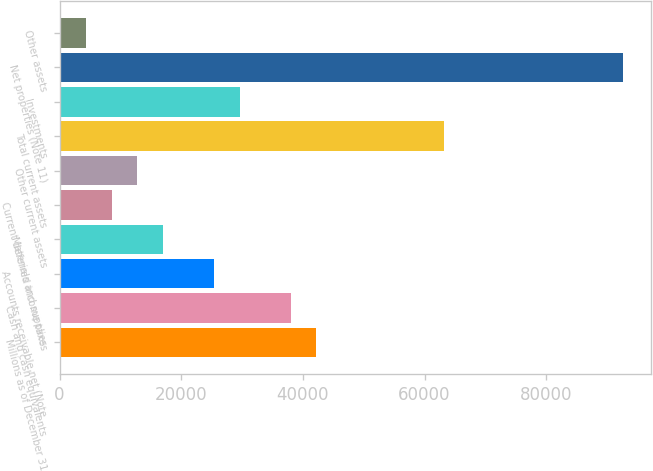Convert chart. <chart><loc_0><loc_0><loc_500><loc_500><bar_chart><fcel>Millions as of December 31<fcel>Cash and cash equivalents<fcel>Accounts receivable net (Note<fcel>Materials and supplies<fcel>Current deferred income taxes<fcel>Other current assets<fcel>Total current assets<fcel>Investments<fcel>Net properties (Note 11)<fcel>Other assets<nl><fcel>42184<fcel>37986.8<fcel>25395.2<fcel>17000.8<fcel>8606.4<fcel>12803.6<fcel>63170<fcel>29592.4<fcel>92550.4<fcel>4409.2<nl></chart> 